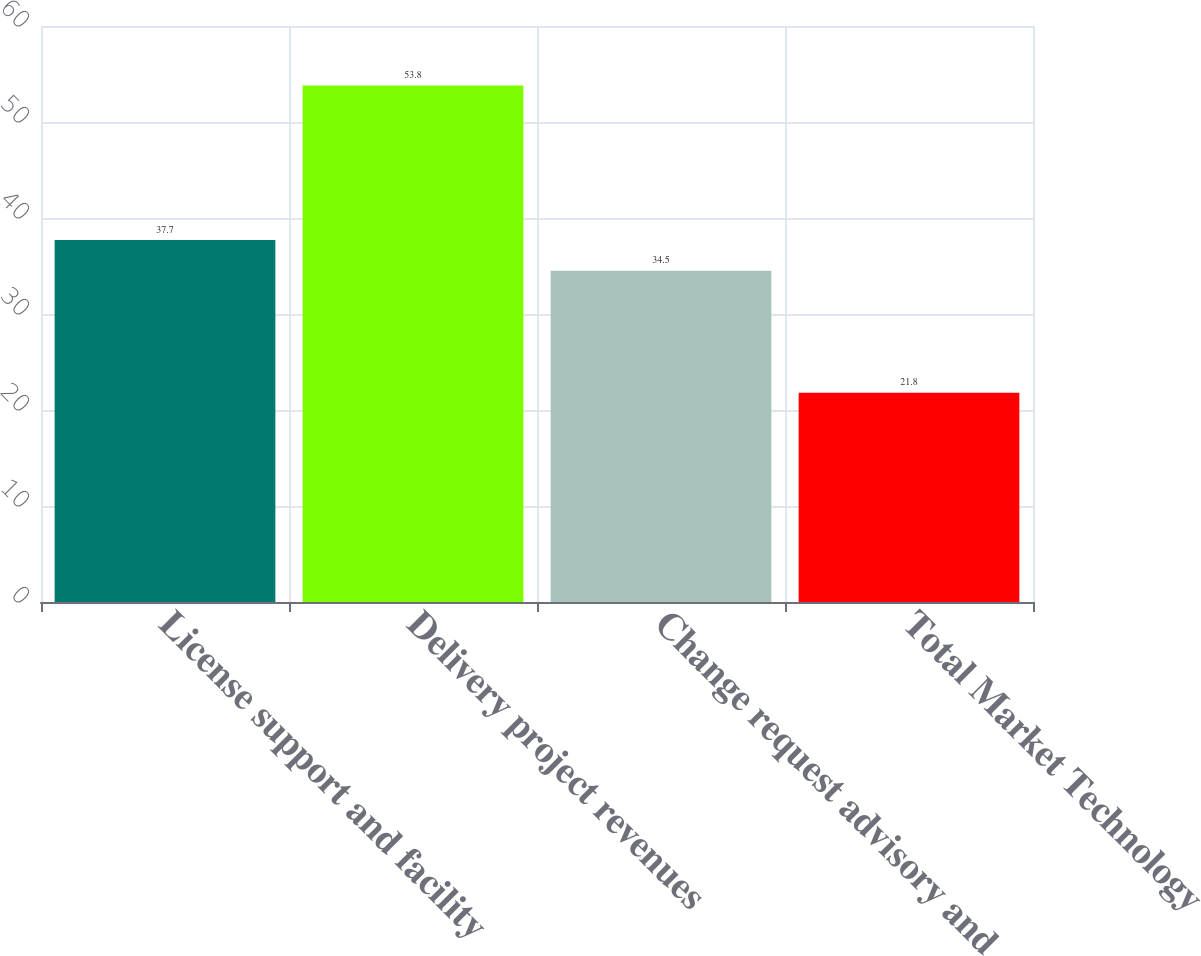Convert chart to OTSL. <chart><loc_0><loc_0><loc_500><loc_500><bar_chart><fcel>License support and facility<fcel>Delivery project revenues<fcel>Change request advisory and<fcel>Total Market Technology<nl><fcel>37.7<fcel>53.8<fcel>34.5<fcel>21.8<nl></chart> 